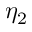<formula> <loc_0><loc_0><loc_500><loc_500>\eta _ { 2 }</formula> 